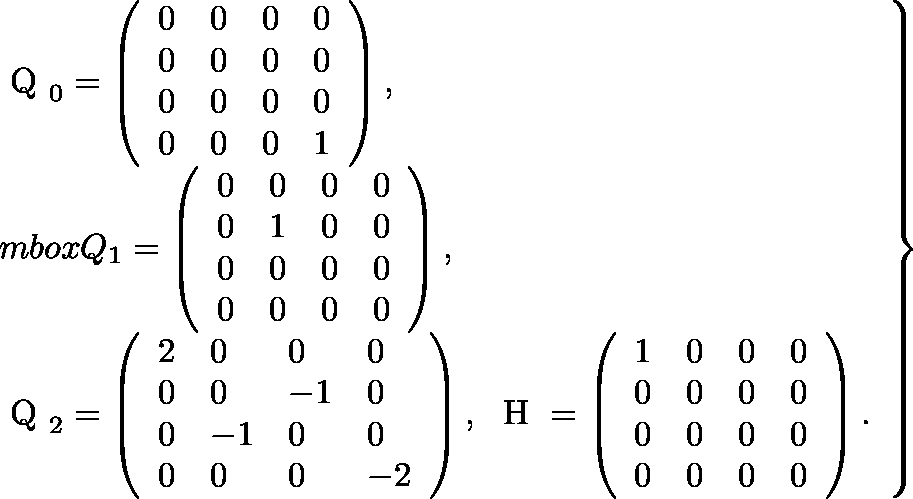<formula> <loc_0><loc_0><loc_500><loc_500>\begin{array} { r } { \begin{array} { l } { \boldmath Q _ { 0 } = \left ( \begin{array} { l l l l } { 0 } & { 0 } & { 0 } & { 0 } \\ { 0 } & { 0 } & { 0 } & { 0 } \\ { 0 } & { 0 } & { 0 } & { 0 } \\ { 0 } & { 0 } & { 0 } & { 1 } \end{array} \right ) , } \\ { m b o x { \boldmath Q } _ { 1 } = \left ( \begin{array} { l l l l } { 0 } & { 0 } & { 0 } & { 0 } \\ { 0 } & { 1 } & { 0 } & { 0 } \\ { 0 } & { 0 } & { 0 } & { 0 } \\ { 0 } & { 0 } & { 0 } & { 0 } \end{array} \right ) , } \\ { \boldmath Q _ { 2 } = \left ( \begin{array} { l l l l } { 2 } & { 0 } & { 0 } & { 0 } \\ { 0 } & { 0 } & { - 1 } & { 0 } \\ { 0 } & { - 1 } & { 0 } & { 0 } \\ { 0 } & { 0 } & { 0 } & { - 2 } \end{array} \right ) , \ \boldmath H = \left ( \begin{array} { l l l l } { 1 } & { 0 } & { 0 } & { 0 } \\ { 0 } & { 0 } & { 0 } & { 0 } \\ { 0 } & { 0 } & { 0 } & { 0 } \\ { 0 } & { 0 } & { 0 } & { 0 } \end{array} \right ) . } \end{array} \right \} } \end{array}</formula> 